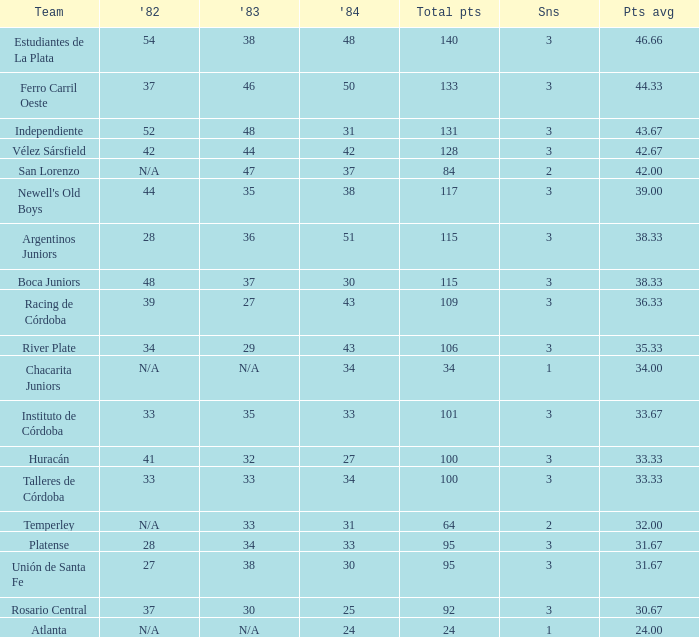What is the points total for the team with points average more than 34, 1984 score more than 37 and N/A in 1982? 0.0. 